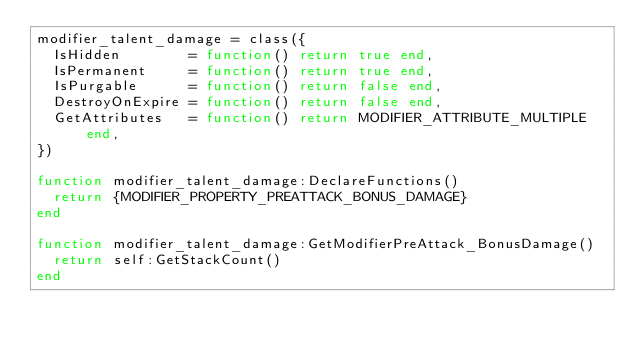Convert code to text. <code><loc_0><loc_0><loc_500><loc_500><_Lua_>modifier_talent_damage = class({
	IsHidden        = function() return true end,
	IsPermanent     = function() return true end,
	IsPurgable      = function() return false end,
	DestroyOnExpire = function() return false end,
	GetAttributes   = function() return MODIFIER_ATTRIBUTE_MULTIPLE end,
})

function modifier_talent_damage:DeclareFunctions()
	return {MODIFIER_PROPERTY_PREATTACK_BONUS_DAMAGE}
end

function modifier_talent_damage:GetModifierPreAttack_BonusDamage()
	return self:GetStackCount()
end
</code> 